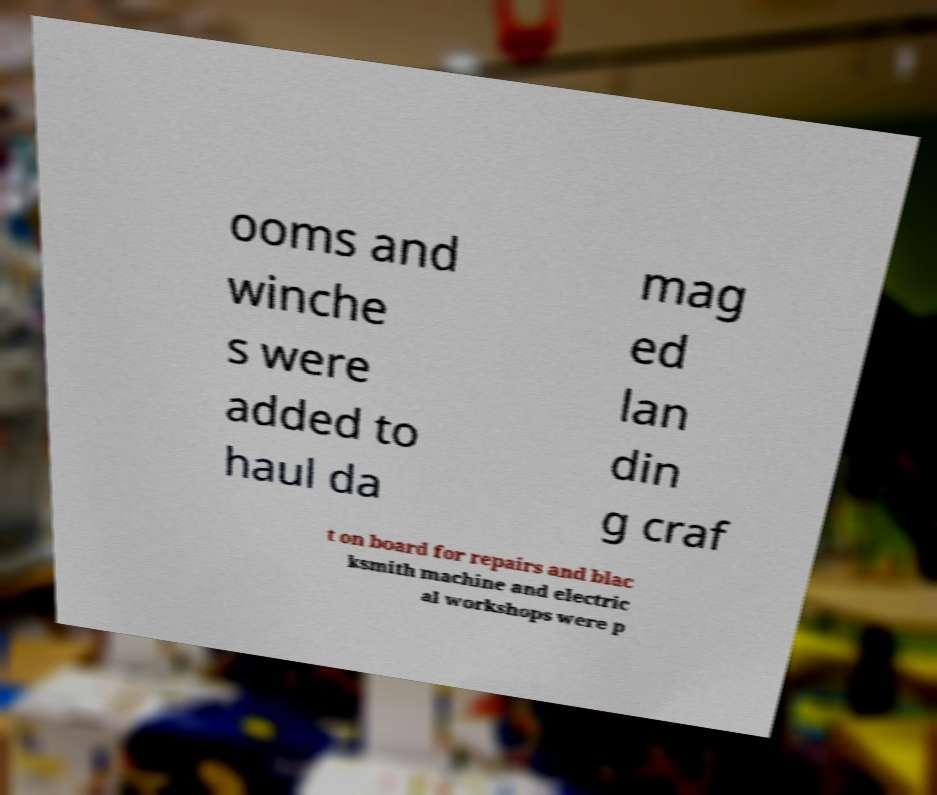Can you accurately transcribe the text from the provided image for me? ooms and winche s were added to haul da mag ed lan din g craf t on board for repairs and blac ksmith machine and electric al workshops were p 